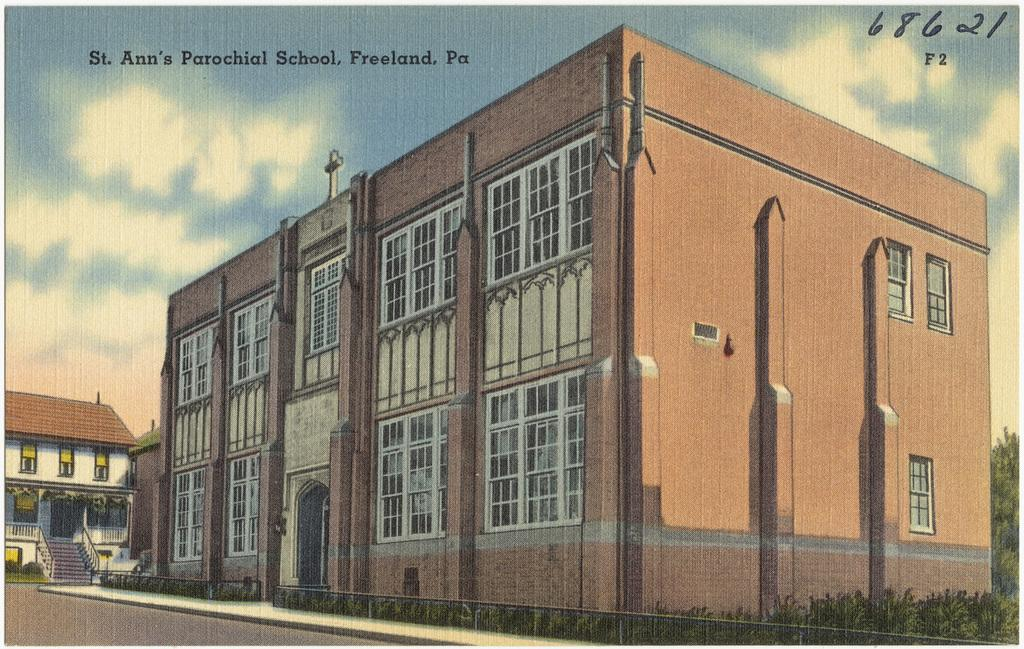<image>
Present a compact description of the photo's key features. A postcard from St. Ann's Parochial school in Freeland, PA. 